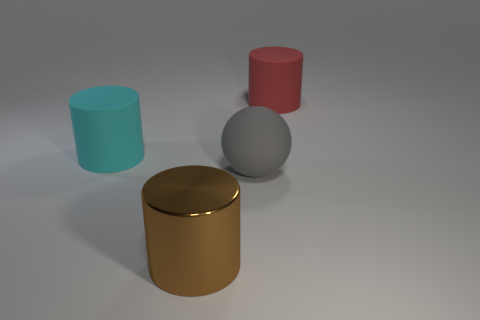Add 2 large yellow blocks. How many objects exist? 6 Subtract all matte cylinders. How many cylinders are left? 1 Subtract all cyan cylinders. How many cylinders are left? 2 Subtract 1 cylinders. How many cylinders are left? 2 Add 3 large red cylinders. How many large red cylinders are left? 4 Add 4 large brown metallic cylinders. How many large brown metallic cylinders exist? 5 Subtract 0 cyan blocks. How many objects are left? 4 Subtract all spheres. How many objects are left? 3 Subtract all brown cylinders. Subtract all red cubes. How many cylinders are left? 2 Subtract all yellow spheres. How many brown cylinders are left? 1 